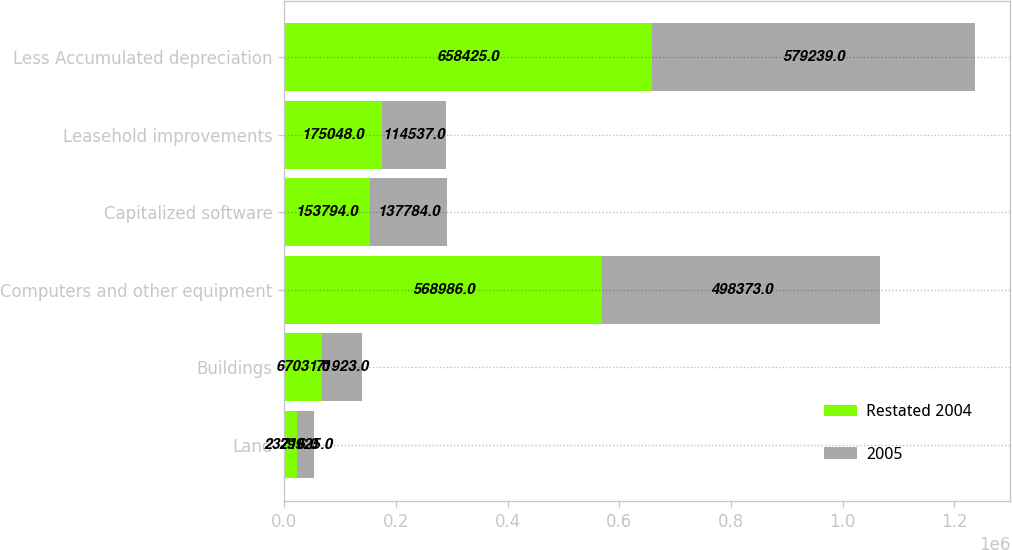Convert chart. <chart><loc_0><loc_0><loc_500><loc_500><stacked_bar_chart><ecel><fcel>Land<fcel>Buildings<fcel>Computers and other equipment<fcel>Capitalized software<fcel>Leasehold improvements<fcel>Less Accumulated depreciation<nl><fcel>Restated 2004<fcel>23716<fcel>67031<fcel>568986<fcel>153794<fcel>175048<fcel>658425<nl><fcel>2005<fcel>29925<fcel>71923<fcel>498373<fcel>137784<fcel>114537<fcel>579239<nl></chart> 